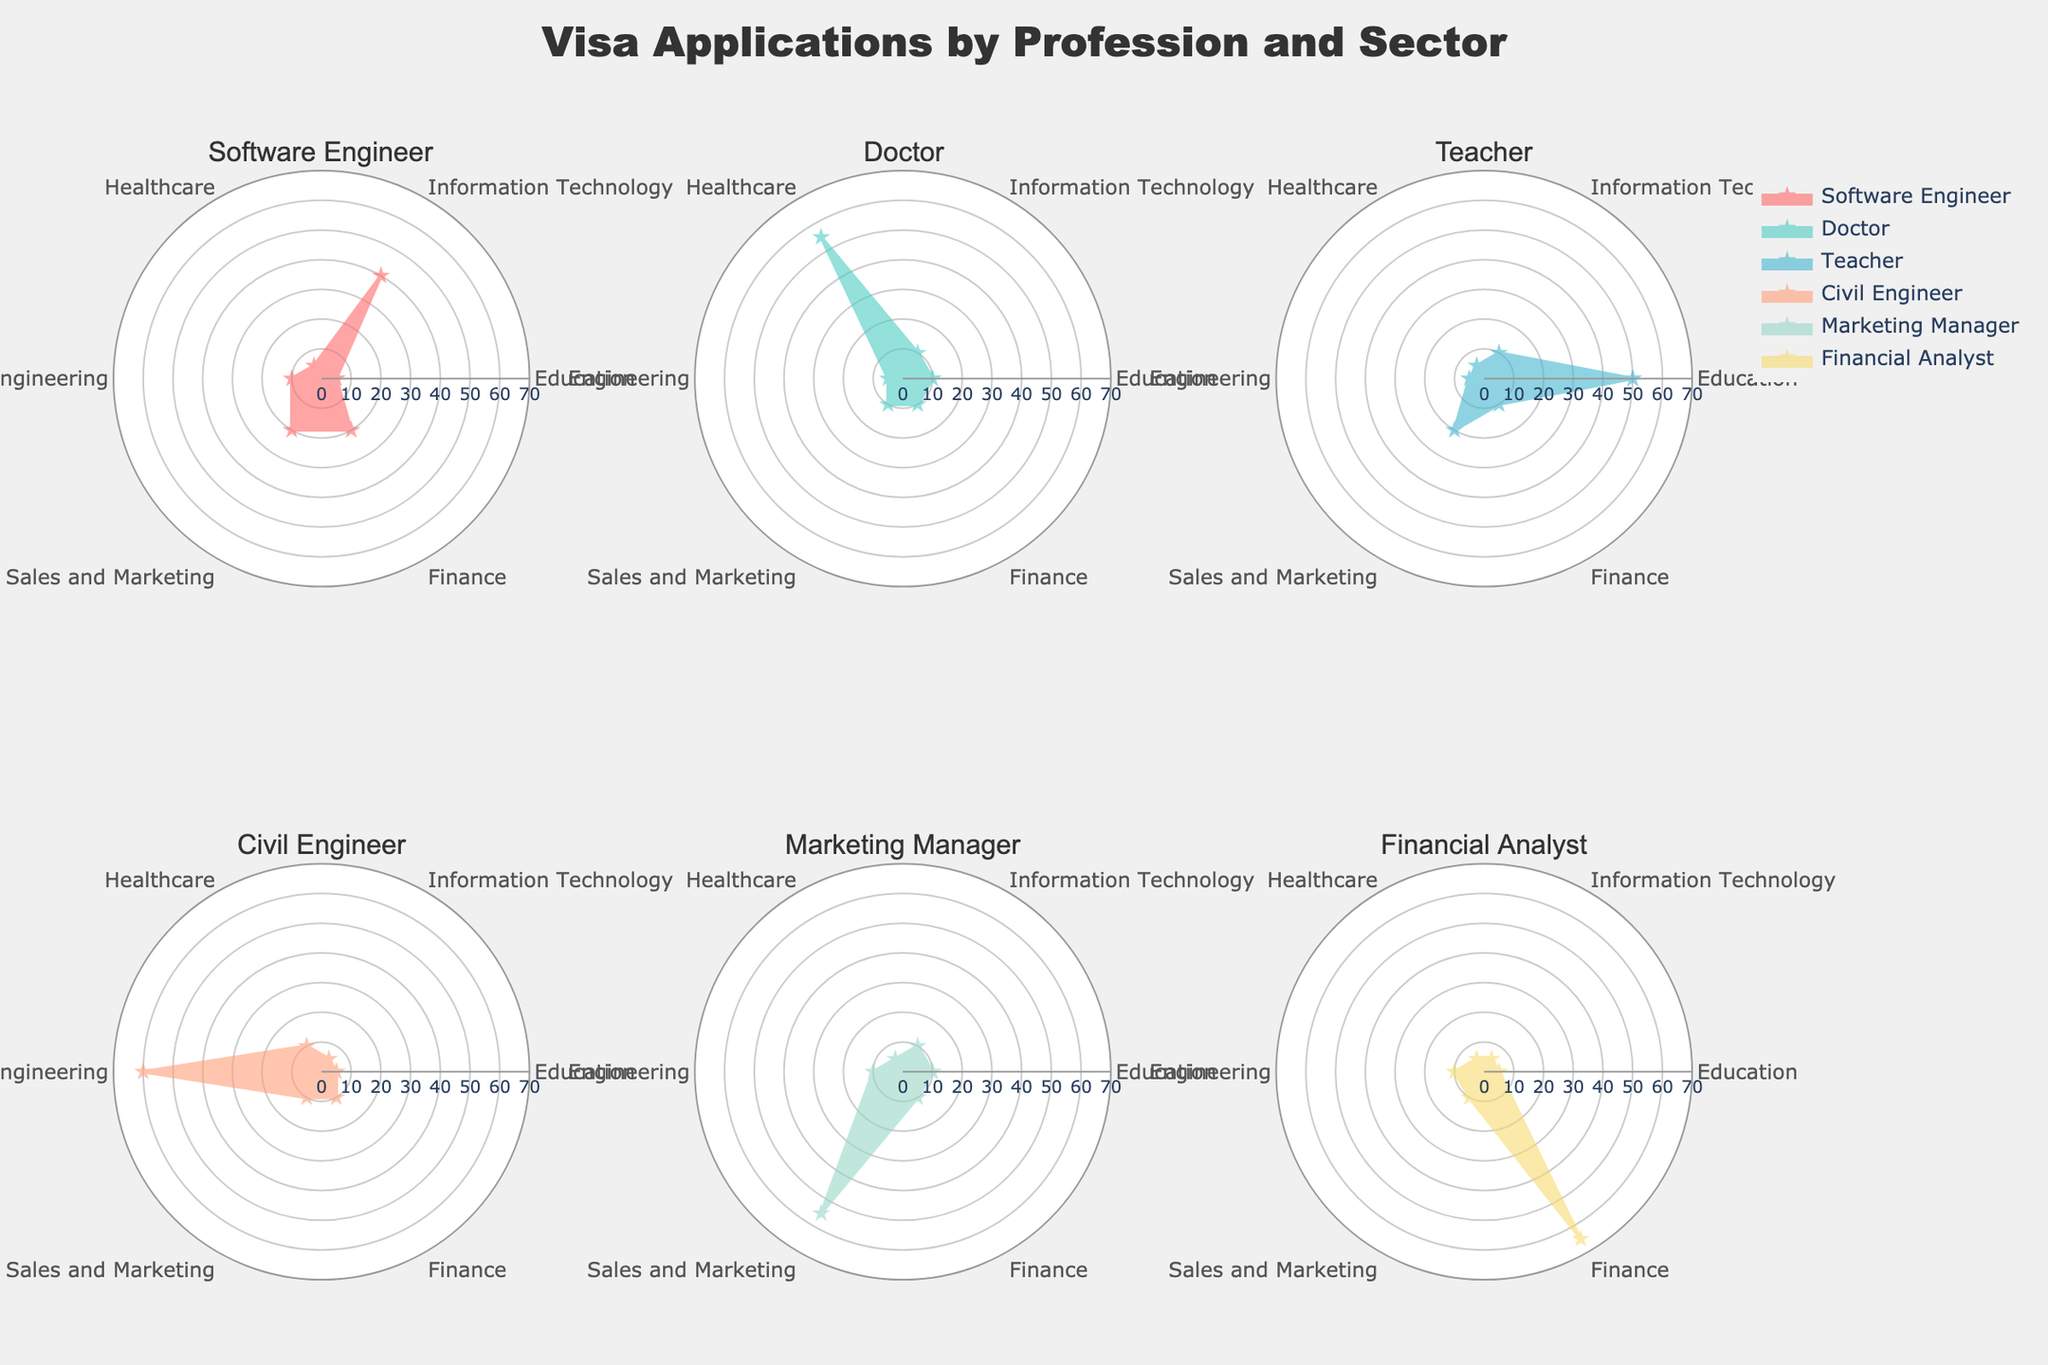what is the title of the figure? The title is located at the top center of the plot. It reads "Visa Applications by Profession and Sector."
Answer: Visa Applications by Profession and Sector How many professions are shown in the radar charts? The subplot titles above each radar chart indicate the different professions. Counting these titles, there are six professions.
Answer: Six Which profession shows the highest percentage in the Information Technology sector? In the Information Technology sector, the profession with the highest percentage will have the largest value in that sector's segment. The Software Engineer has the highest value at 40%.
Answer: Software Engineer What is the percentage of visa applications for the Teacher profession in the Education sector? The radar chart for the Teacher profession shows the segment for the Education sector at the largest data point. This data point is labeled as 50%.
Answer: 50% Compare the values in the Finance sector for Software Engineer and Financial Analyst professions. Which one is higher? Looking at the radar charts, the Software Engineer is at 20%, whereas the Financial Analyst is at 65% in the Finance sector. The Financial Analyst has a higher value.
Answer: Financial Analyst Which profession has the lowest percentage in the Healthcare sector? By examining the Healthcare sector across each radar chart, the Financial Analyst and Teacher both show a value at 5%, which is the lowest.
Answer: Financial Analyst & Teacher Calculate the average percentage of visa applications in the Sales and Marketing sector for all professions. Sum the percentages for Sales and Marketing across all professions and divide by the number of professions. Values are: 20, 10, 20, 10, 55, 10. Sum = 125, divided by 6 = 20.83%.
Answer: 20.83% Which profession has equal percentages in two different sectors? Checking each radar chart, the Software Engineer has 20% in both the Sales and Marketing and Finance sectors.
Answer: Software Engineer Describe the pattern of the radar chart for the Civil Engineer profession in terms of visa application distribution across sectors. The Civil Engineer radar chart shows a dominant value in Engineering (60%), with equal lower values in Education (5%), Information Technology (5%), Healthcare (10%), Sales and Marketing (10%), and Finance (10%).
Answer: Dominant in Engineering with equal lower values in other sectors 